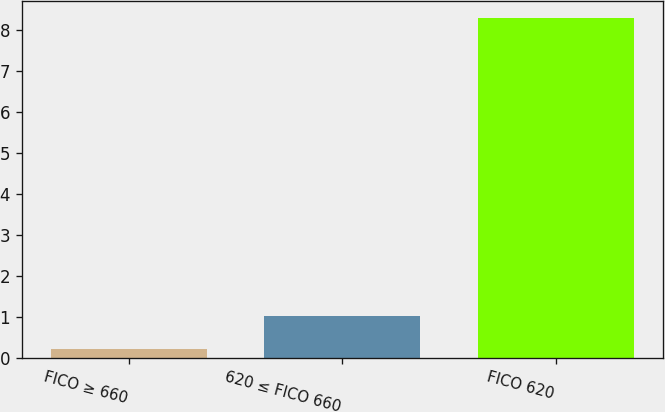Convert chart. <chart><loc_0><loc_0><loc_500><loc_500><bar_chart><fcel>FICO ≥ 660<fcel>620 ≤ FICO 660<fcel>FICO 620<nl><fcel>0.2<fcel>1.01<fcel>8.3<nl></chart> 